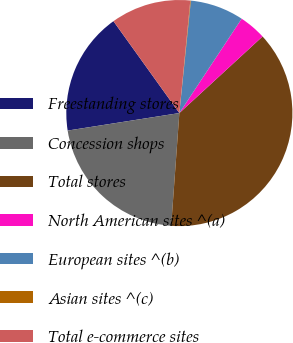Convert chart to OTSL. <chart><loc_0><loc_0><loc_500><loc_500><pie_chart><fcel>Freestanding stores<fcel>Concession shops<fcel>Total stores<fcel>North American sites ^(a)<fcel>European sites ^(b)<fcel>Asian sites ^(c)<fcel>Total e-commerce sites<nl><fcel>17.57%<fcel>21.37%<fcel>37.99%<fcel>3.87%<fcel>7.66%<fcel>0.08%<fcel>11.45%<nl></chart> 